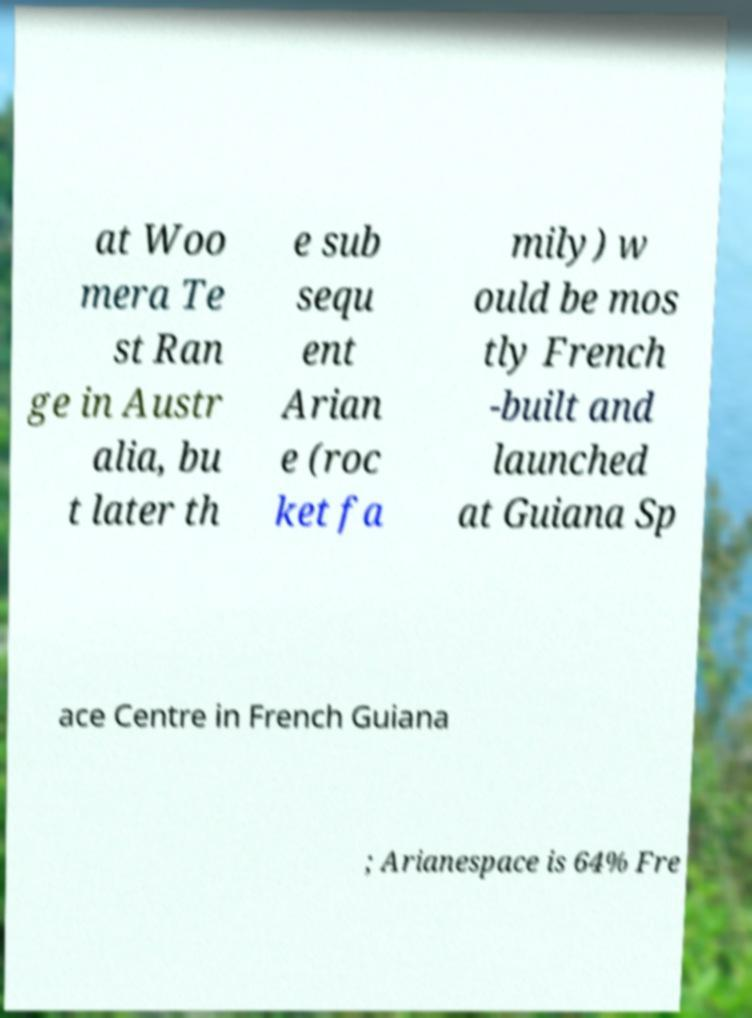Could you assist in decoding the text presented in this image and type it out clearly? at Woo mera Te st Ran ge in Austr alia, bu t later th e sub sequ ent Arian e (roc ket fa mily) w ould be mos tly French -built and launched at Guiana Sp ace Centre in French Guiana ; Arianespace is 64% Fre 